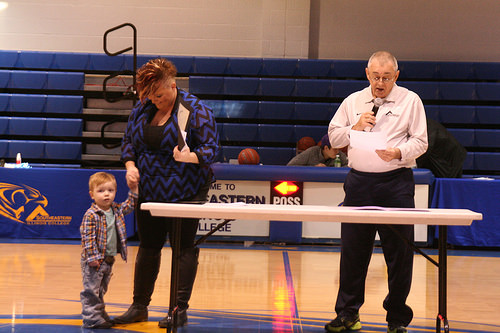<image>
Is there a boy in front of the man? No. The boy is not in front of the man. The spatial positioning shows a different relationship between these objects. 